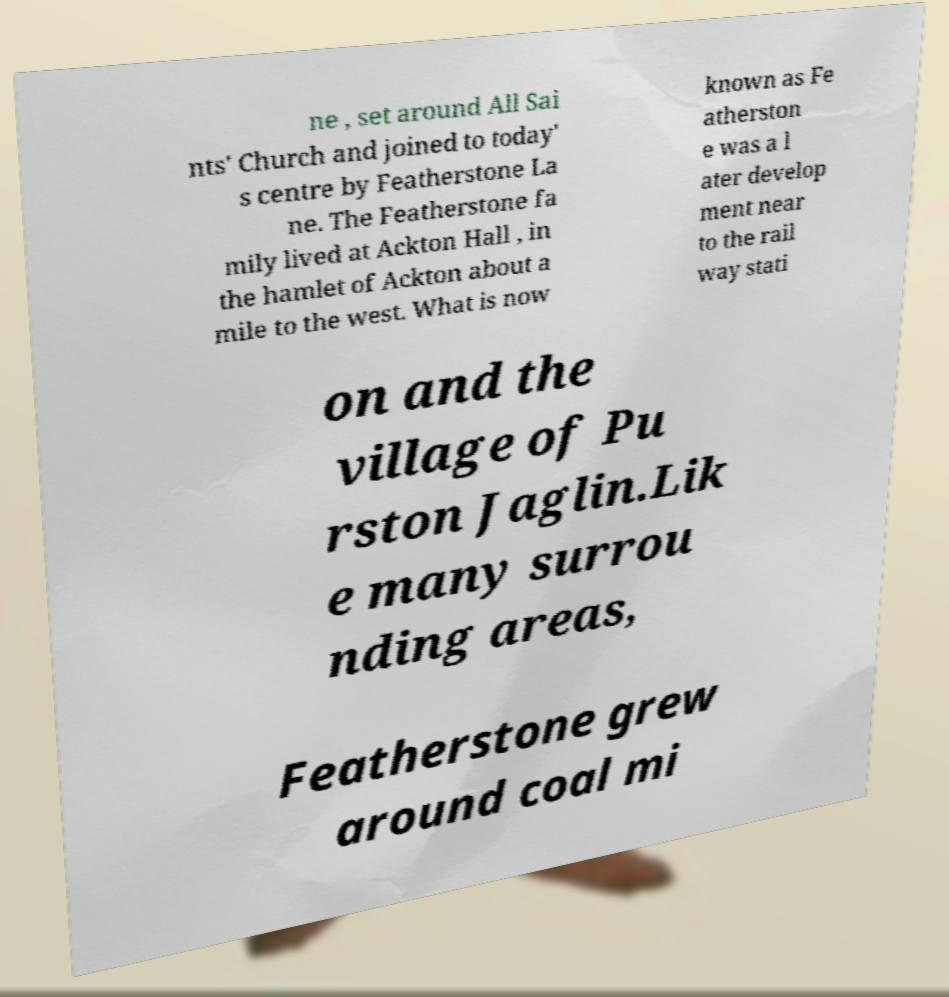Please read and relay the text visible in this image. What does it say? ne , set around All Sai nts' Church and joined to today' s centre by Featherstone La ne. The Featherstone fa mily lived at Ackton Hall , in the hamlet of Ackton about a mile to the west. What is now known as Fe atherston e was a l ater develop ment near to the rail way stati on and the village of Pu rston Jaglin.Lik e many surrou nding areas, Featherstone grew around coal mi 